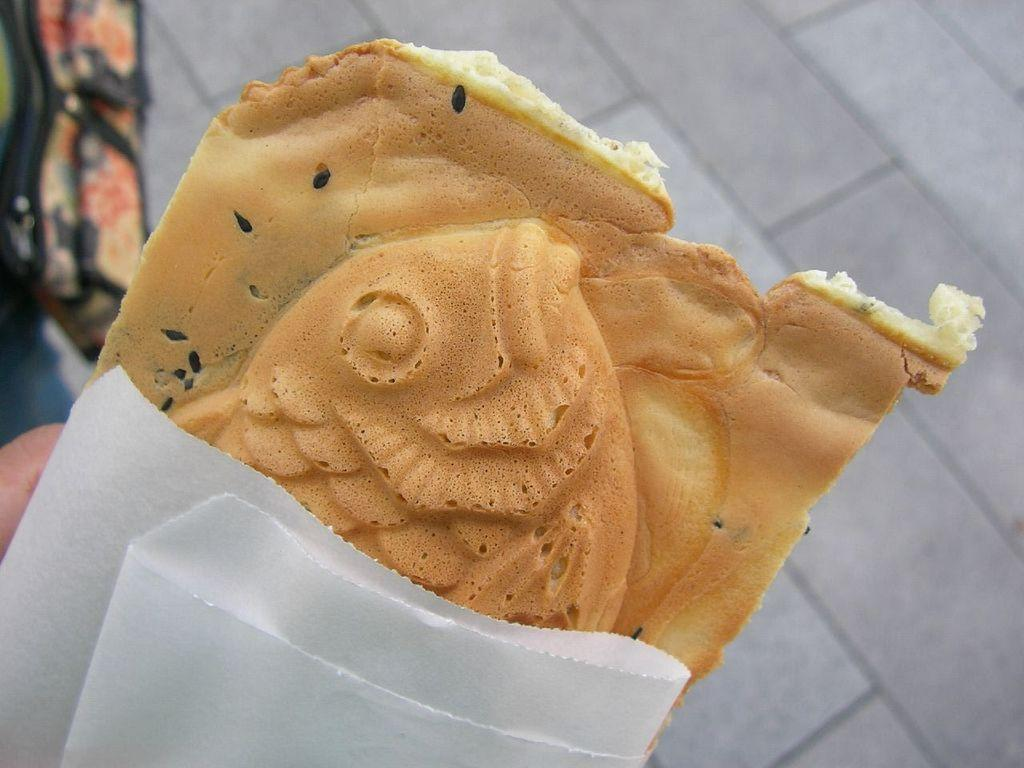What is located in the foreground of the picture? There is bread in the foreground of the picture. What is the person in the foreground holding? A person is holding a paper in the foreground. What can be seen in the background of the picture? There is a bag in the background of the picture, and the floor is also visible. How does the person's breath affect the bread in the image? There is no indication of the person's breath affecting the bread in the image. What type of can is visible in the image? There is no can present in the image. 